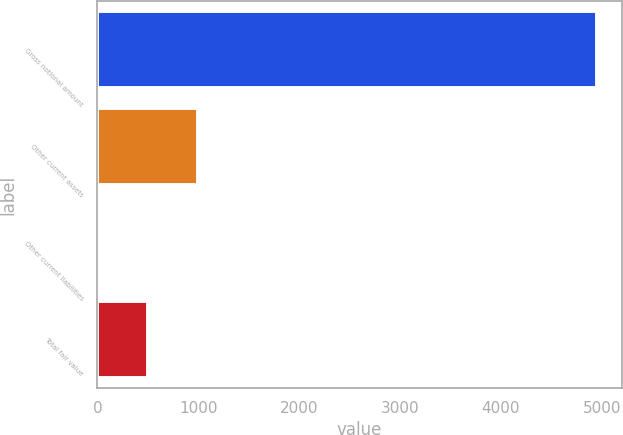Convert chart to OTSL. <chart><loc_0><loc_0><loc_500><loc_500><bar_chart><fcel>Gross notional amount<fcel>Other current assets<fcel>Other current liabilities<fcel>Total fair value<nl><fcel>4950<fcel>997.2<fcel>9<fcel>503.1<nl></chart> 